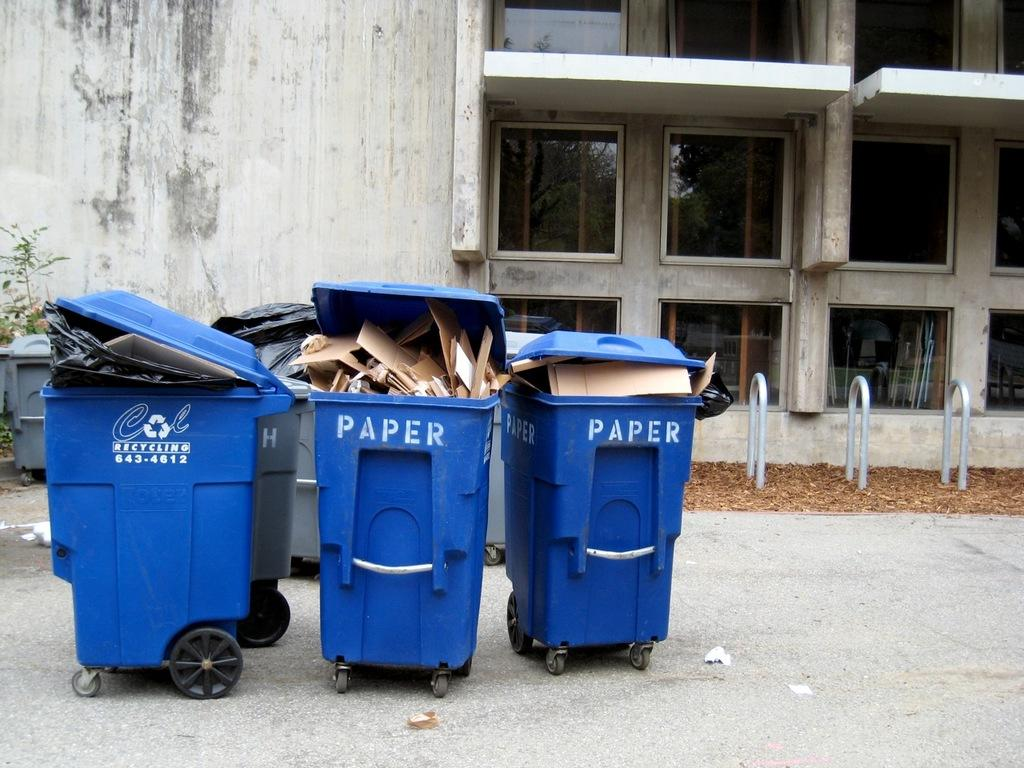<image>
Describe the image concisely. Three blue recycling bins that says PAPER on it outside. 